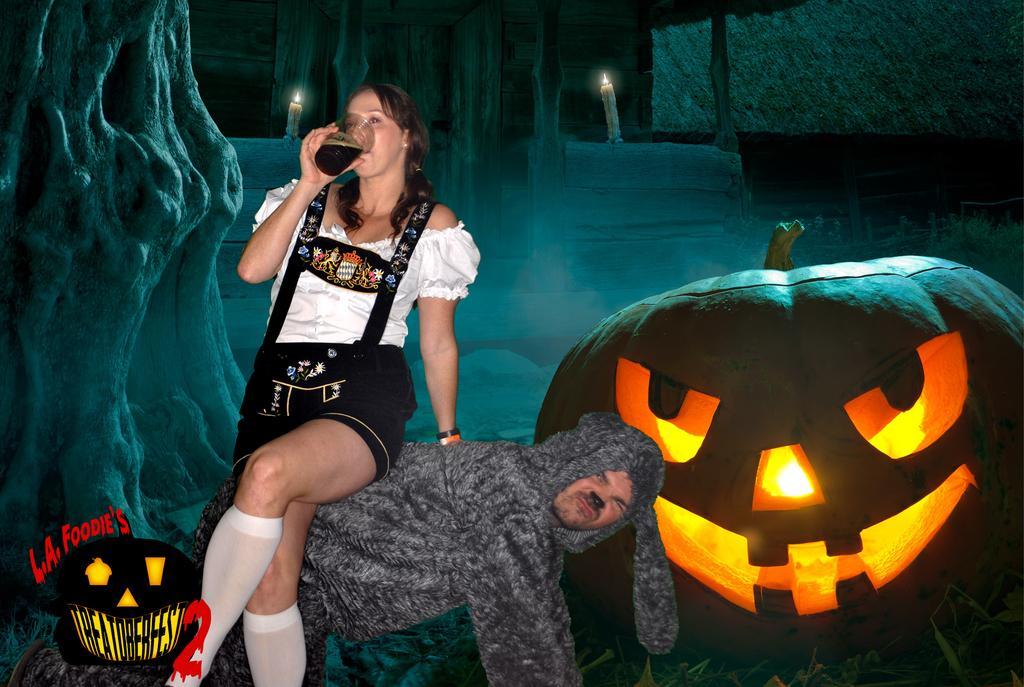In one or two sentences, can you explain what this image depicts? In this picture we can observe a woman sitting on a man wearing a costume which is in grey color. She is drinking, holding a glass in her hand. We can observe large pumpkin on the right side. In the background there are two candles and a wall. 